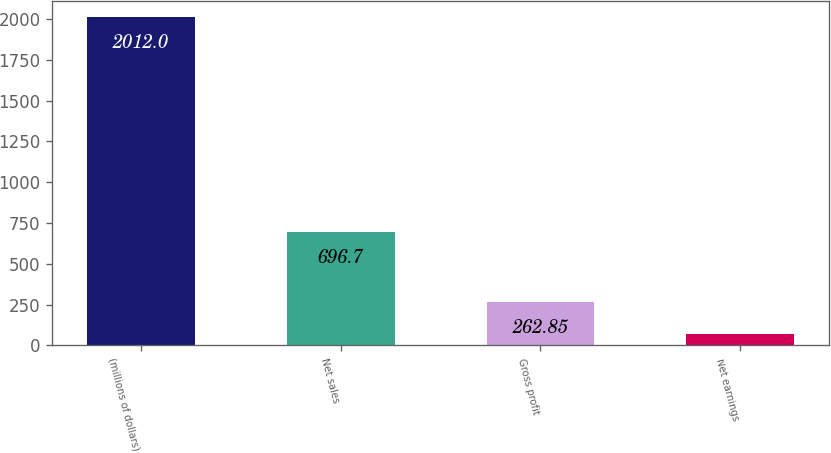<chart> <loc_0><loc_0><loc_500><loc_500><bar_chart><fcel>(millions of dollars)<fcel>Net sales<fcel>Gross profit<fcel>Net earnings<nl><fcel>2012<fcel>696.7<fcel>262.85<fcel>68.5<nl></chart> 